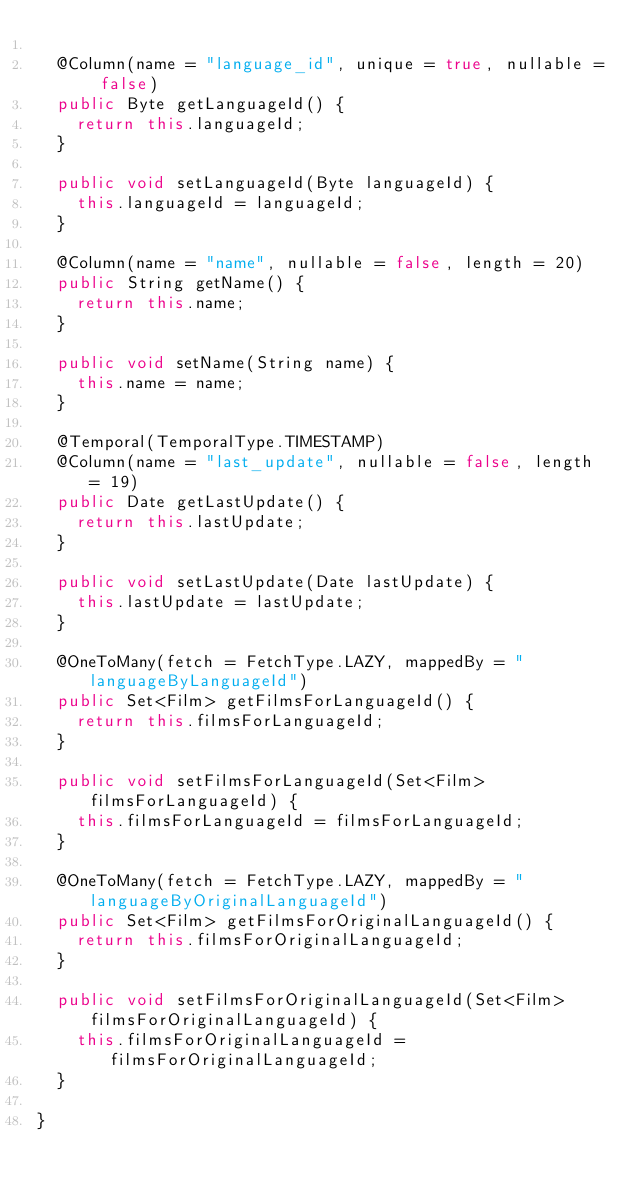Convert code to text. <code><loc_0><loc_0><loc_500><loc_500><_Java_>
	@Column(name = "language_id", unique = true, nullable = false)
	public Byte getLanguageId() {
		return this.languageId;
	}

	public void setLanguageId(Byte languageId) {
		this.languageId = languageId;
	}

	@Column(name = "name", nullable = false, length = 20)
	public String getName() {
		return this.name;
	}

	public void setName(String name) {
		this.name = name;
	}

	@Temporal(TemporalType.TIMESTAMP)
	@Column(name = "last_update", nullable = false, length = 19)
	public Date getLastUpdate() {
		return this.lastUpdate;
	}

	public void setLastUpdate(Date lastUpdate) {
		this.lastUpdate = lastUpdate;
	}

	@OneToMany(fetch = FetchType.LAZY, mappedBy = "languageByLanguageId")
	public Set<Film> getFilmsForLanguageId() {
		return this.filmsForLanguageId;
	}

	public void setFilmsForLanguageId(Set<Film> filmsForLanguageId) {
		this.filmsForLanguageId = filmsForLanguageId;
	}

	@OneToMany(fetch = FetchType.LAZY, mappedBy = "languageByOriginalLanguageId")
	public Set<Film> getFilmsForOriginalLanguageId() {
		return this.filmsForOriginalLanguageId;
	}

	public void setFilmsForOriginalLanguageId(Set<Film> filmsForOriginalLanguageId) {
		this.filmsForOriginalLanguageId = filmsForOriginalLanguageId;
	}

}
</code> 